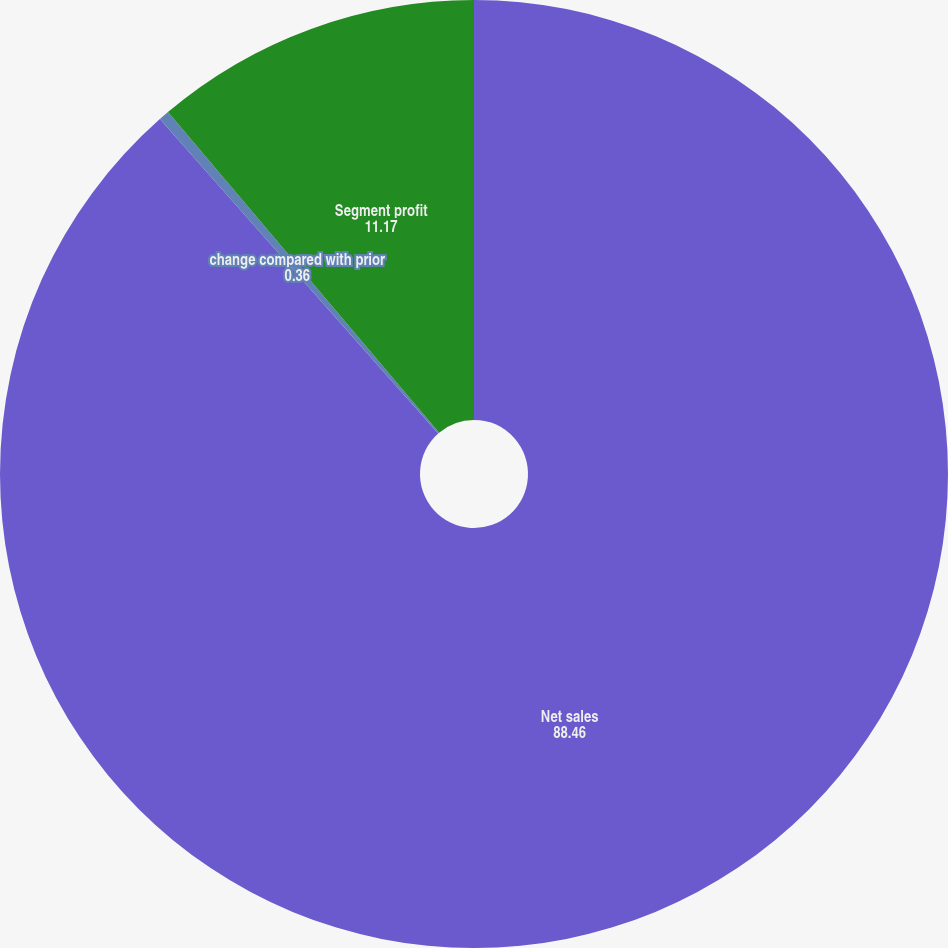<chart> <loc_0><loc_0><loc_500><loc_500><pie_chart><fcel>Net sales<fcel>change compared with prior<fcel>Segment profit<nl><fcel>88.46%<fcel>0.36%<fcel>11.17%<nl></chart> 